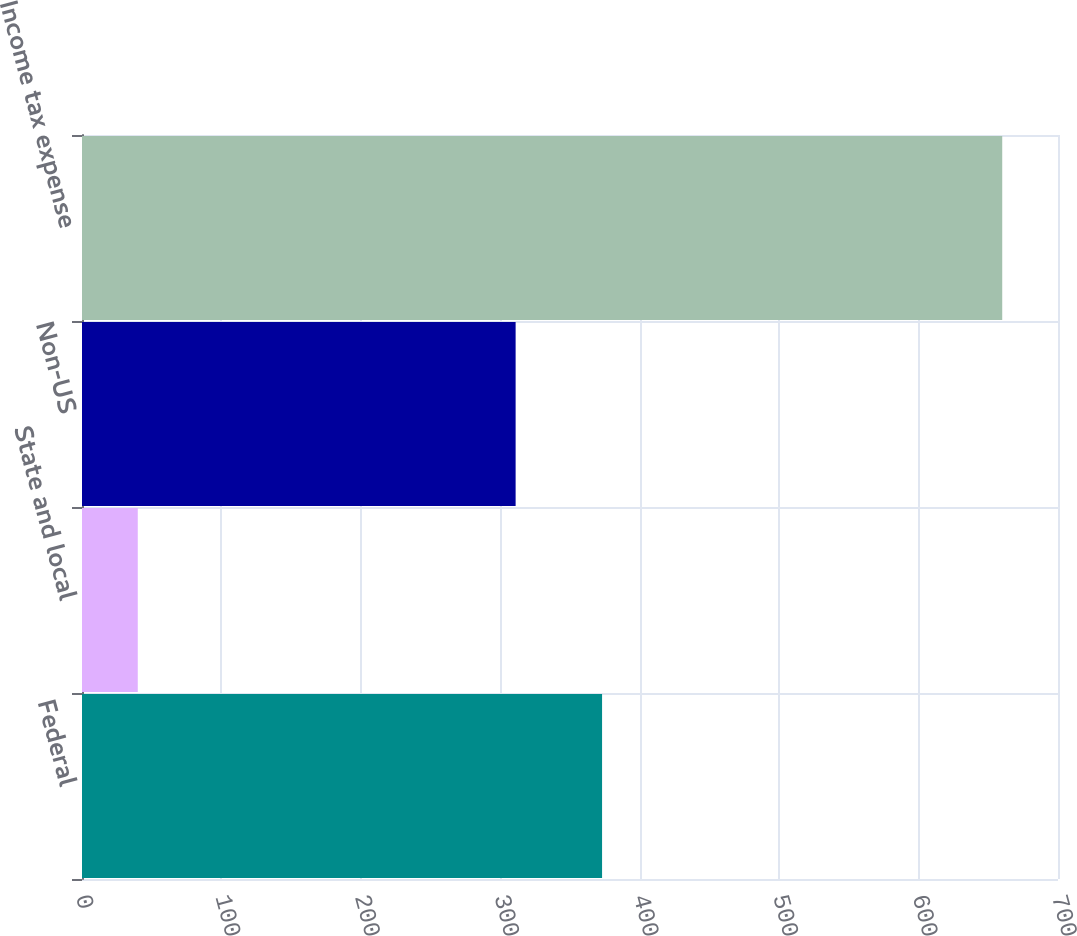<chart> <loc_0><loc_0><loc_500><loc_500><bar_chart><fcel>Federal<fcel>State and local<fcel>Non-US<fcel>Income tax expense<nl><fcel>373<fcel>40<fcel>311<fcel>660<nl></chart> 